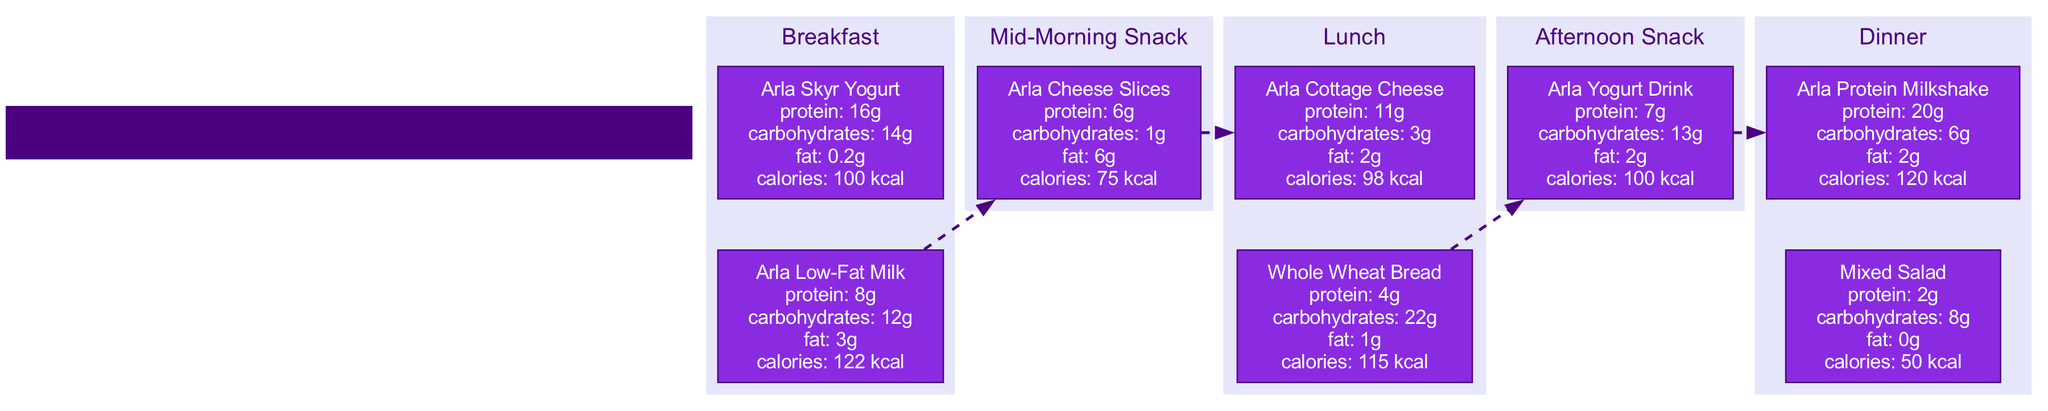What item at breakfast has the highest protein content? At breakfast, the Arla Skyr Yogurt has 16g of protein, while the Arla Low-Fat Milk has 8g. Comparing these amounts, Arla Skyr Yogurt stands out with the highest protein content.
Answer: Arla Skyr Yogurt How many components are included in the lunch block? The lunch block contains two components: Arla Cottage Cheese and Whole Wheat Bread. Counting these, we find that the number of components in the lunch block is two.
Answer: 2 What is the total calorie intake from the afternoon snack? The afternoon snack consists of one item, the Arla Yogurt Drink, which has 100 kcal. Therefore, the total calorie intake from the afternoon snack is simply the calorie value of this single item.
Answer: 100 kcal Which meal contains a source of carbohydrates with 22g? Upon reviewing the diagram, it is clear that the Whole Wheat Bread at lunch contains 22g of carbohydrates, which is the only item listed with this quantity.
Answer: Whole Wheat Bread What is the average protein content from all meals? To calculate the average protein, we sum the total protein from each meal. Breakfast has 24g (16g + 8g), Mid-Morning Snack has 6g, Lunch has 15g (11g + 4g), Afternoon Snack has 7g, and Dinner has 22g (20g + 2g). The total protein is 24g + 6g + 15g + 7g + 22g = 74g. Dividing by the number of meals (5) gives an average of 14.8g per meal.
Answer: 14.8g Which snack has the least amount of carbohydrates? The mid-morning snack consists of Arla Cheese Slices which only have 1g of carbohydrates, whereas all other snacks have more carbohydrates. Thus, it has the least carbohydrates of all the snacks.
Answer: Arla Cheese Slices 